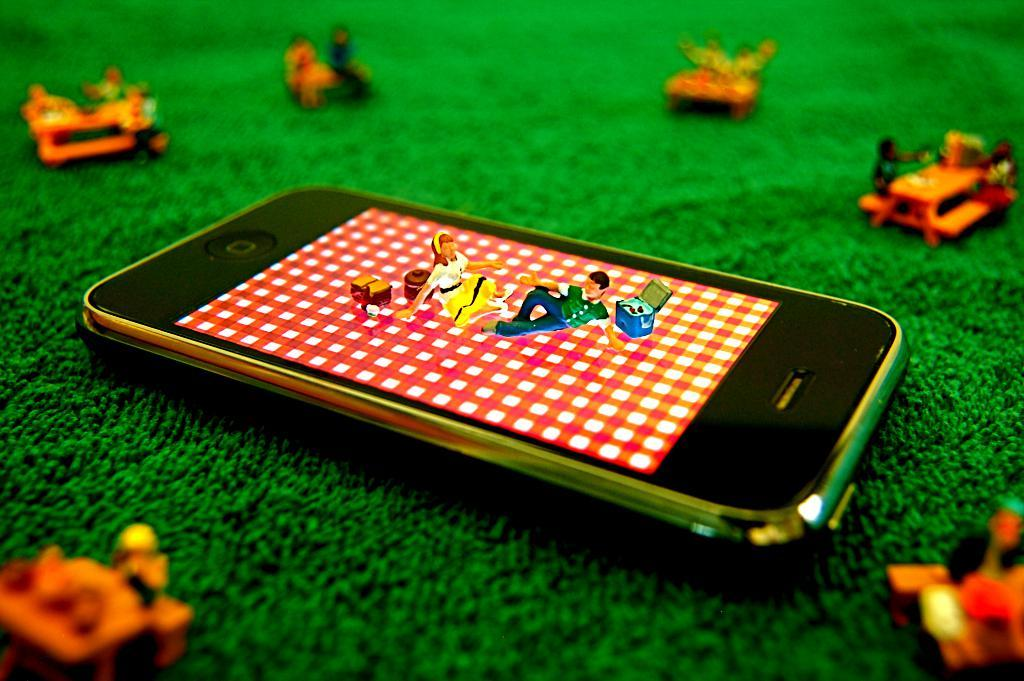What is the main object in the center of the image? There is a mobile phone in the center of the image. What other items can be seen in the image besides the mobile phone? There are toys in the image. What type of army is depicted in the image? There is no army or military theme present in the image. What color of paint is being used on the toys in the image? There is no paint or painting activity depicted in the image. 